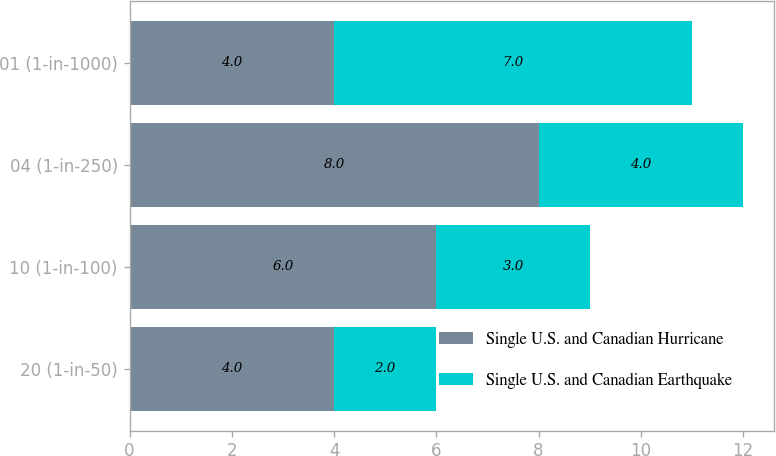Convert chart to OTSL. <chart><loc_0><loc_0><loc_500><loc_500><stacked_bar_chart><ecel><fcel>20 (1-in-50)<fcel>10 (1-in-100)<fcel>04 (1-in-250)<fcel>01 (1-in-1000)<nl><fcel>Single U.S. and Canadian Hurricane<fcel>4<fcel>6<fcel>8<fcel>4<nl><fcel>Single U.S. and Canadian Earthquake<fcel>2<fcel>3<fcel>4<fcel>7<nl></chart> 